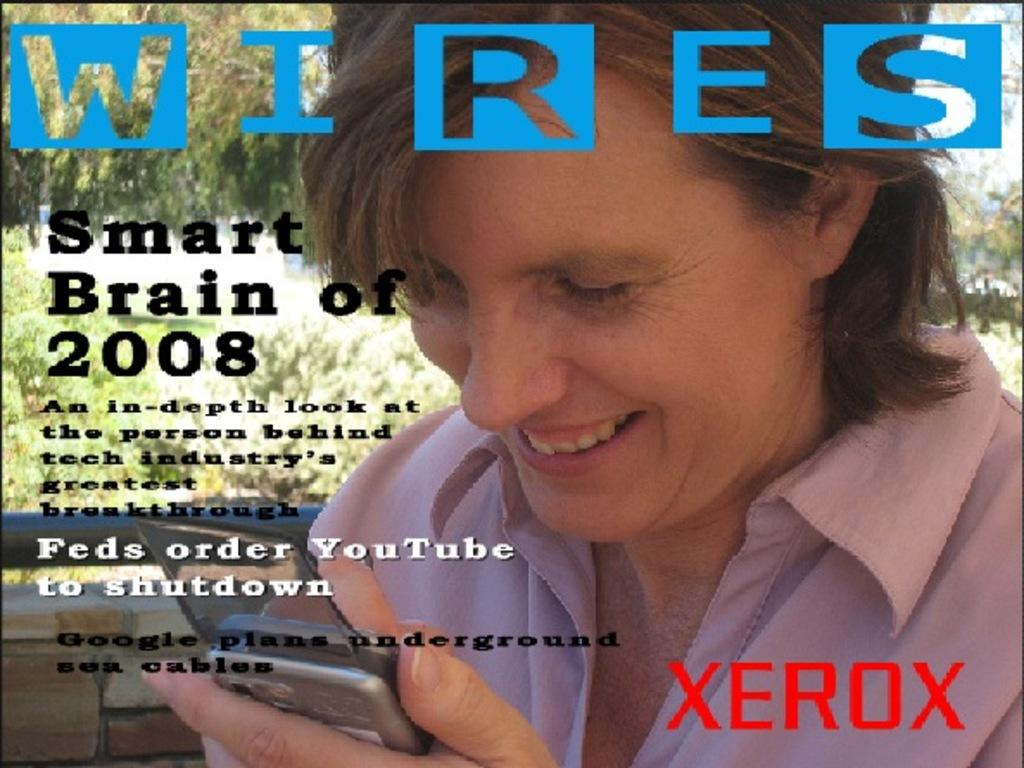Who is the main subject in the image? There is a lady in the image. What is the lady holding in her hand? The lady is holding a mobile in her hand. Can you describe any additional details about the image? There is text written on the image. What type of tramp can be seen in the image? There is no tramp present in the image. Does the lady have a tail in the image? The lady does not have a tail in the image. 